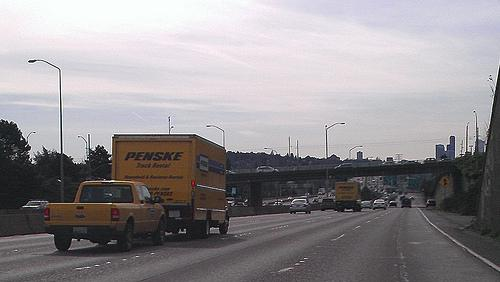Question: what company are the two moving vans?
Choices:
A. Graebel.
B. Hertz.
C. U-Haul.
D. Penske.
Answer with the letter. Answer: D Question: what is going over the freeway?
Choices:
A. A train.
B. A suspension bridge.
C. A walkway.
D. An overpass.
Answer with the letter. Answer: D Question: what plant is on the far left of the photo?
Choices:
A. A rosebush.
B. A tree.
C. A cactus.
D. A fern.
Answer with the letter. Answer: B Question: what are the cars driving on?
Choices:
A. A parking garage.
B. A country road.
C. A freeway.
D. A racetrack.
Answer with the letter. Answer: C Question: where is this photo taken?
Choices:
A. A pasture.
B. A desert.
C. A farm.
D. A freeway.
Answer with the letter. Answer: D Question: how many lanes on on the freeway?
Choices:
A. Three.
B. Two.
C. Four.
D. Five.
Answer with the letter. Answer: C 